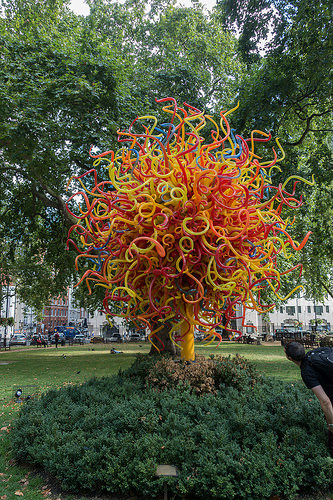<image>
Can you confirm if the person is under the tree? No. The person is not positioned under the tree. The vertical relationship between these objects is different. 